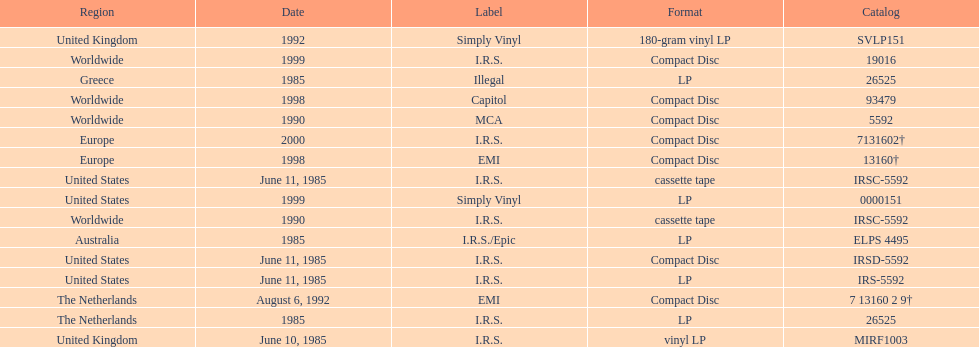Which country or region had the most releases? Worldwide. 